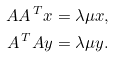<formula> <loc_0><loc_0><loc_500><loc_500>A A ^ { \, T } x & = \lambda \mu x , \\ A ^ { \, T } A y & = \lambda \mu y .</formula> 